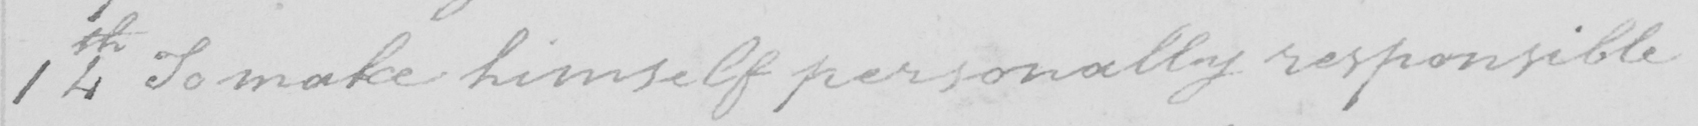What text is written in this handwritten line? 14th To make himself personally responsible 